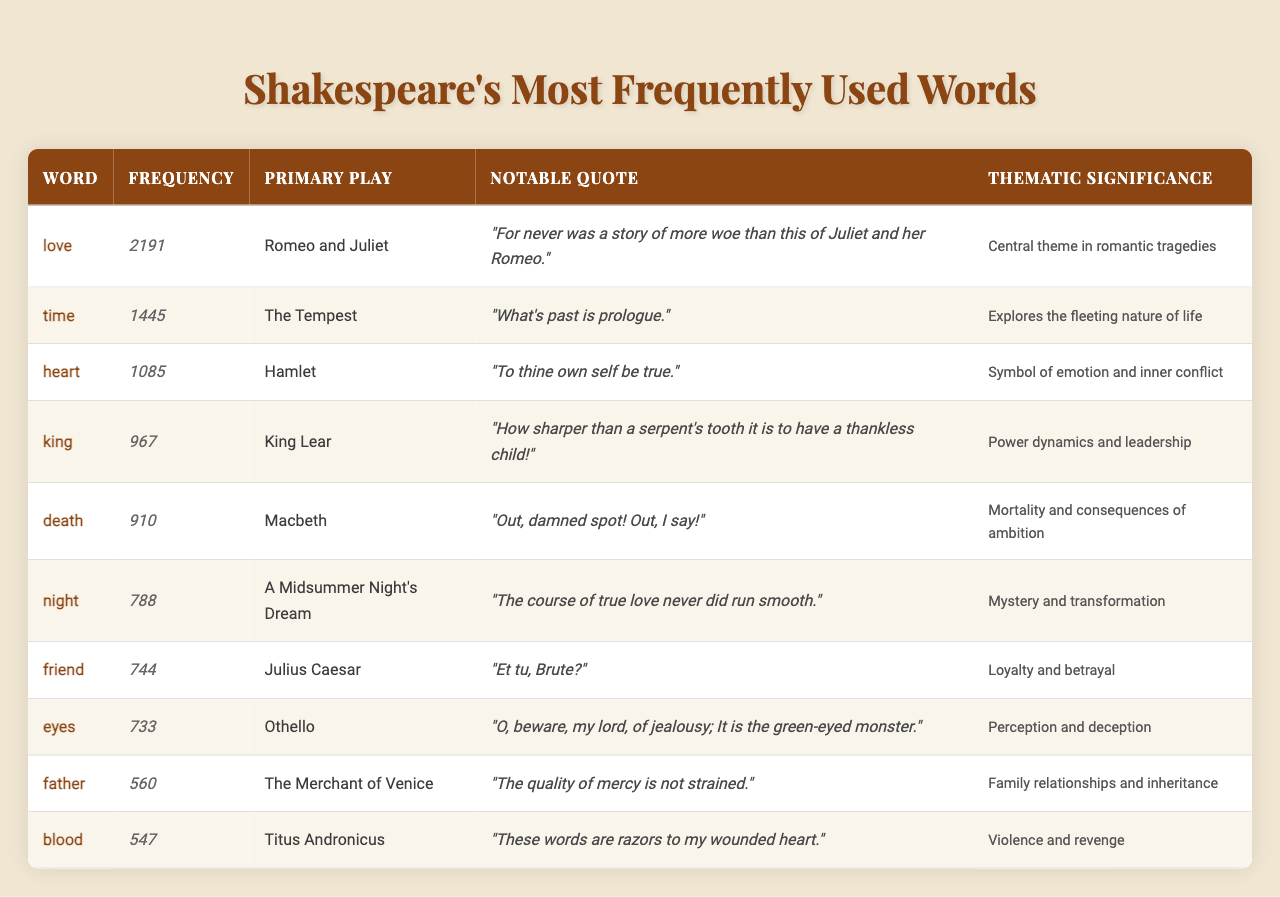What is the word that appears most frequently in Shakespeare's works? The table indicates that the word "love" has the highest frequency, totaling 2191 occurrences.
Answer: love Which play is associated with the word "king"? The table shows that the word "king" is primarily associated with the play "King Lear."
Answer: King Lear What is the frequency of the word "death"? According to the table, the word "death" appears 910 times.
Answer: 910 Which word has the lowest frequency and what is its value? The word with the lowest frequency is "blood," which appears 547 times.
Answer: blood, 547 What is the thematic significance of the word "eyes"? The thematic significance of "eyes" relates to perception and deception, as detailed in the table.
Answer: Perception and deception What is the average frequency of the listed words? The total frequency is 10,968 (sum of all frequencies). There are 10 words, so the average is 10,968 / 10 = 1096.8.
Answer: 1096.8 Which notable quote is associated with “friend”? The notable quote associated with "friend" is "Et tu, Brute?" as shown in the table.
Answer: Et tu, Brute? Is "time" used more frequently than "heart"? The frequency of "time" is 1445, while "heart" is 1085; therefore, "time" is used more frequently.
Answer: Yes Which thematic significance is linked to the word "death"? The thematic significance linked to the word "death" focuses on mortality and the consequences of ambition.
Answer: Mortality and consequences of ambition How many more times does the word "love" occur compared to "friend"? The frequency of "love" is 2191, and for "friend," it is 744. The difference is 2191 - 744 = 1447.
Answer: 1447 